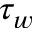Convert formula to latex. <formula><loc_0><loc_0><loc_500><loc_500>\tau _ { w }</formula> 